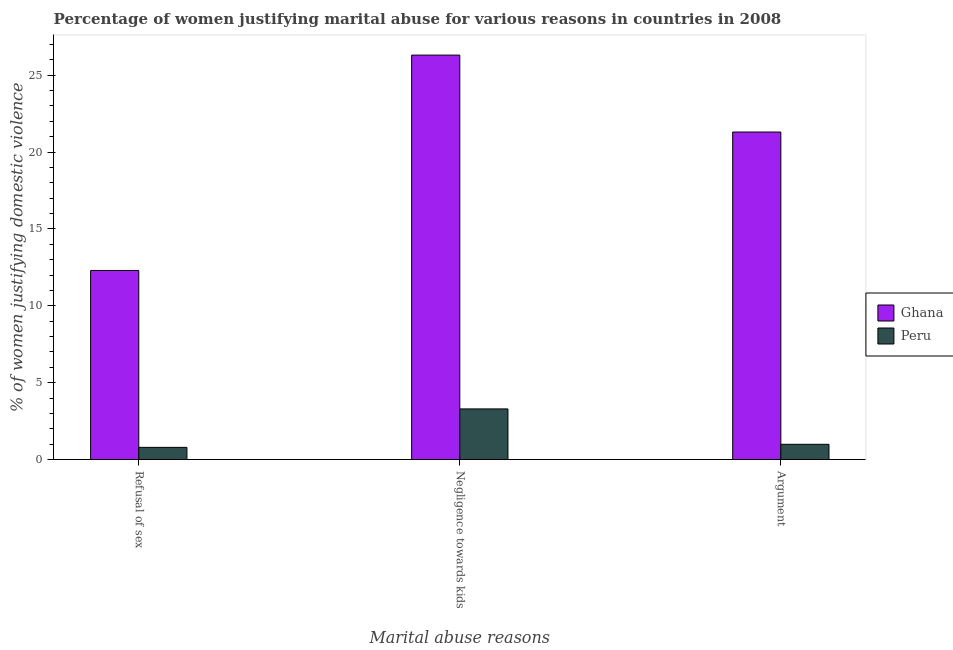How many different coloured bars are there?
Your response must be concise. 2. How many groups of bars are there?
Your answer should be compact. 3. Are the number of bars on each tick of the X-axis equal?
Your response must be concise. Yes. How many bars are there on the 1st tick from the right?
Offer a terse response. 2. What is the label of the 2nd group of bars from the left?
Your answer should be very brief. Negligence towards kids. What is the percentage of women justifying domestic violence due to negligence towards kids in Ghana?
Offer a terse response. 26.3. Across all countries, what is the maximum percentage of women justifying domestic violence due to negligence towards kids?
Give a very brief answer. 26.3. In which country was the percentage of women justifying domestic violence due to refusal of sex maximum?
Provide a short and direct response. Ghana. In which country was the percentage of women justifying domestic violence due to negligence towards kids minimum?
Give a very brief answer. Peru. What is the total percentage of women justifying domestic violence due to arguments in the graph?
Provide a short and direct response. 22.3. What is the difference between the percentage of women justifying domestic violence due to refusal of sex in Peru and the percentage of women justifying domestic violence due to negligence towards kids in Ghana?
Your answer should be compact. -25.5. What is the average percentage of women justifying domestic violence due to refusal of sex per country?
Your answer should be compact. 6.55. What is the difference between the percentage of women justifying domestic violence due to arguments and percentage of women justifying domestic violence due to refusal of sex in Peru?
Make the answer very short. 0.2. What is the ratio of the percentage of women justifying domestic violence due to arguments in Peru to that in Ghana?
Give a very brief answer. 0.05. Is the percentage of women justifying domestic violence due to arguments in Ghana less than that in Peru?
Offer a terse response. No. Is the difference between the percentage of women justifying domestic violence due to negligence towards kids in Peru and Ghana greater than the difference between the percentage of women justifying domestic violence due to refusal of sex in Peru and Ghana?
Provide a short and direct response. No. What is the difference between the highest and the second highest percentage of women justifying domestic violence due to refusal of sex?
Ensure brevity in your answer.  11.5. In how many countries, is the percentage of women justifying domestic violence due to refusal of sex greater than the average percentage of women justifying domestic violence due to refusal of sex taken over all countries?
Your answer should be very brief. 1. Is the sum of the percentage of women justifying domestic violence due to refusal of sex in Ghana and Peru greater than the maximum percentage of women justifying domestic violence due to arguments across all countries?
Your answer should be compact. No. Is it the case that in every country, the sum of the percentage of women justifying domestic violence due to refusal of sex and percentage of women justifying domestic violence due to negligence towards kids is greater than the percentage of women justifying domestic violence due to arguments?
Your answer should be very brief. Yes. How many countries are there in the graph?
Your answer should be very brief. 2. Are the values on the major ticks of Y-axis written in scientific E-notation?
Give a very brief answer. No. Does the graph contain any zero values?
Offer a terse response. No. Where does the legend appear in the graph?
Offer a very short reply. Center right. What is the title of the graph?
Keep it short and to the point. Percentage of women justifying marital abuse for various reasons in countries in 2008. Does "Equatorial Guinea" appear as one of the legend labels in the graph?
Give a very brief answer. No. What is the label or title of the X-axis?
Ensure brevity in your answer.  Marital abuse reasons. What is the label or title of the Y-axis?
Offer a very short reply. % of women justifying domestic violence. What is the % of women justifying domestic violence of Ghana in Refusal of sex?
Provide a short and direct response. 12.3. What is the % of women justifying domestic violence in Ghana in Negligence towards kids?
Ensure brevity in your answer.  26.3. What is the % of women justifying domestic violence in Peru in Negligence towards kids?
Provide a succinct answer. 3.3. What is the % of women justifying domestic violence in Ghana in Argument?
Make the answer very short. 21.3. Across all Marital abuse reasons, what is the maximum % of women justifying domestic violence of Ghana?
Offer a terse response. 26.3. Across all Marital abuse reasons, what is the maximum % of women justifying domestic violence of Peru?
Offer a terse response. 3.3. Across all Marital abuse reasons, what is the minimum % of women justifying domestic violence of Ghana?
Offer a terse response. 12.3. Across all Marital abuse reasons, what is the minimum % of women justifying domestic violence in Peru?
Give a very brief answer. 0.8. What is the total % of women justifying domestic violence of Ghana in the graph?
Provide a succinct answer. 59.9. What is the difference between the % of women justifying domestic violence in Ghana in Refusal of sex and that in Argument?
Ensure brevity in your answer.  -9. What is the difference between the % of women justifying domestic violence in Peru in Refusal of sex and that in Argument?
Your answer should be very brief. -0.2. What is the difference between the % of women justifying domestic violence in Peru in Negligence towards kids and that in Argument?
Keep it short and to the point. 2.3. What is the difference between the % of women justifying domestic violence of Ghana in Refusal of sex and the % of women justifying domestic violence of Peru in Negligence towards kids?
Your answer should be very brief. 9. What is the difference between the % of women justifying domestic violence in Ghana in Negligence towards kids and the % of women justifying domestic violence in Peru in Argument?
Offer a very short reply. 25.3. What is the average % of women justifying domestic violence in Ghana per Marital abuse reasons?
Provide a short and direct response. 19.97. What is the difference between the % of women justifying domestic violence of Ghana and % of women justifying domestic violence of Peru in Argument?
Make the answer very short. 20.3. What is the ratio of the % of women justifying domestic violence in Ghana in Refusal of sex to that in Negligence towards kids?
Provide a succinct answer. 0.47. What is the ratio of the % of women justifying domestic violence of Peru in Refusal of sex to that in Negligence towards kids?
Offer a very short reply. 0.24. What is the ratio of the % of women justifying domestic violence in Ghana in Refusal of sex to that in Argument?
Offer a terse response. 0.58. What is the ratio of the % of women justifying domestic violence of Peru in Refusal of sex to that in Argument?
Give a very brief answer. 0.8. What is the ratio of the % of women justifying domestic violence in Ghana in Negligence towards kids to that in Argument?
Provide a short and direct response. 1.23. What is the difference between the highest and the second highest % of women justifying domestic violence of Ghana?
Provide a short and direct response. 5. What is the difference between the highest and the second highest % of women justifying domestic violence of Peru?
Your response must be concise. 2.3. What is the difference between the highest and the lowest % of women justifying domestic violence of Ghana?
Make the answer very short. 14. 